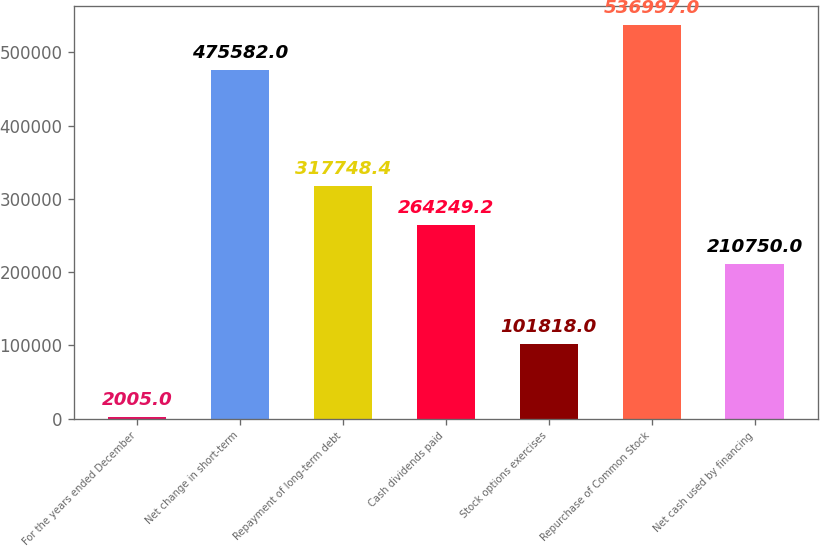Convert chart. <chart><loc_0><loc_0><loc_500><loc_500><bar_chart><fcel>For the years ended December<fcel>Net change in short-term<fcel>Repayment of long-term debt<fcel>Cash dividends paid<fcel>Stock options exercises<fcel>Repurchase of Common Stock<fcel>Net cash used by financing<nl><fcel>2005<fcel>475582<fcel>317748<fcel>264249<fcel>101818<fcel>536997<fcel>210750<nl></chart> 